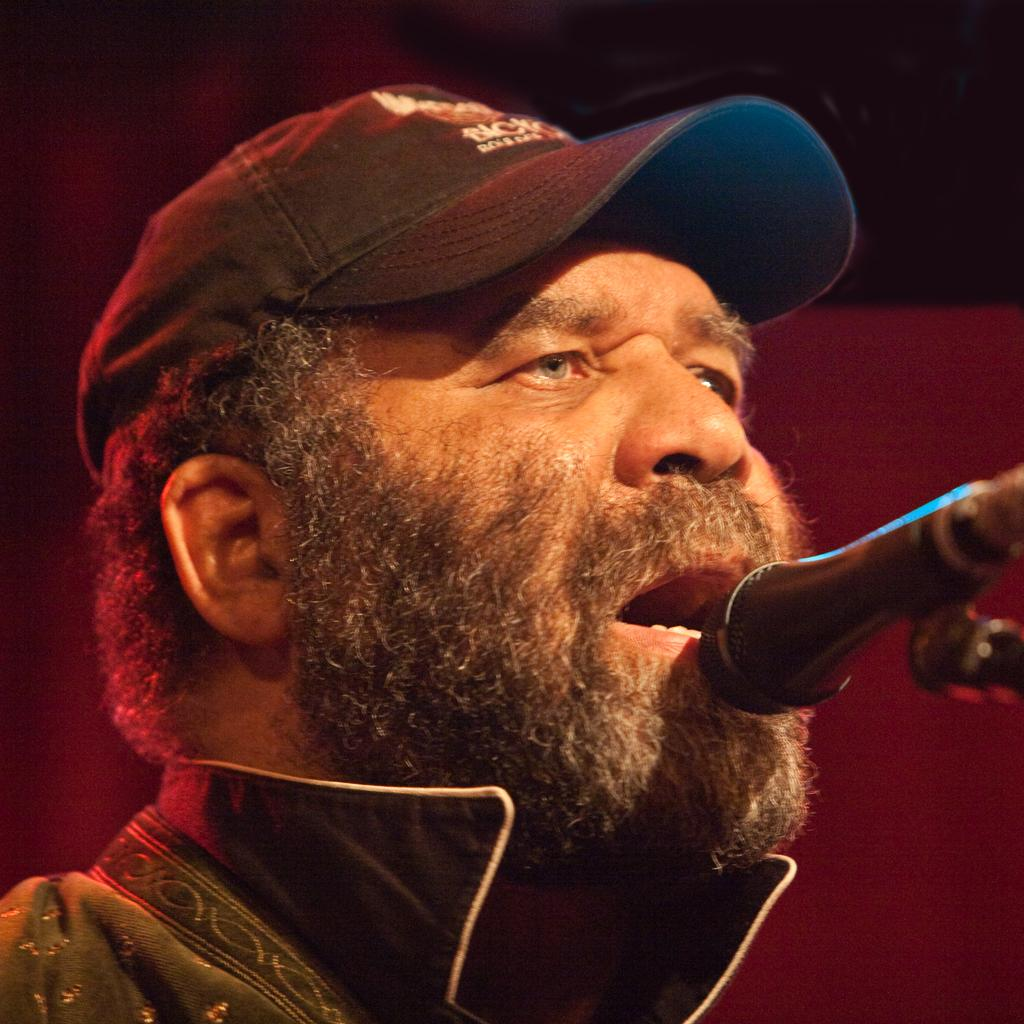Who is the main subject in the image? There is a man in the image. What is the man wearing on his head? The man is wearing a cap. What object is in front of the man's mouth? There is a microphone in front of the man's mouth. What can be observed about the background of the image? The background of the image is dark. How many women are involved in the fight depicted in the image? There is no fight or women present in the image; it features a man with a cap and a microphone in front of his mouth. 